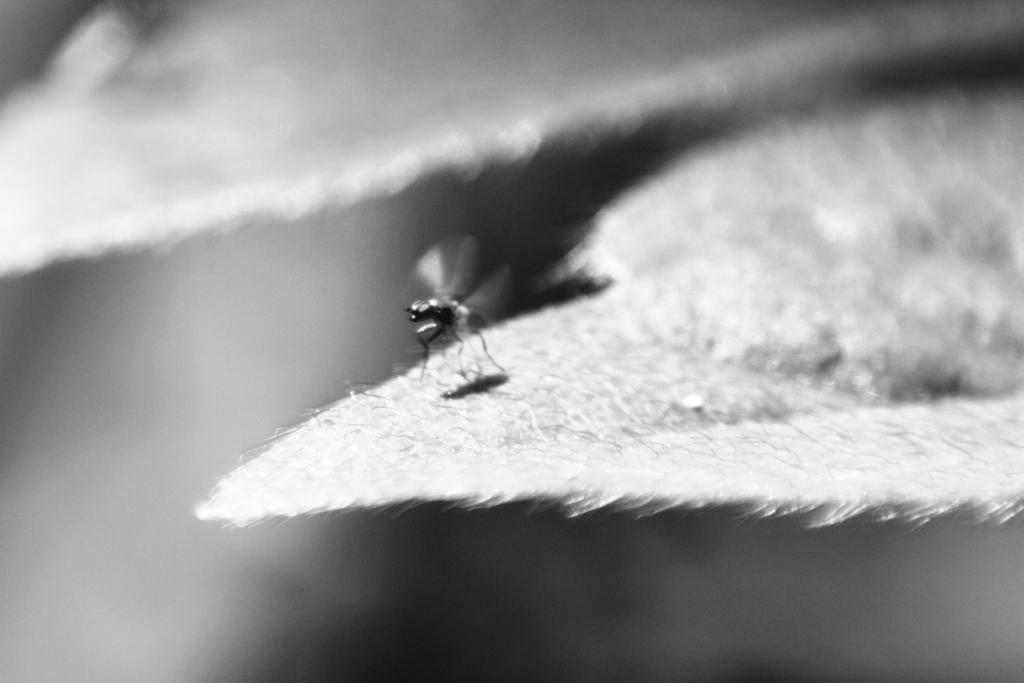What is the color scheme of the image? The image is black and white. What can be seen in the foreground of the image? There is a fly on a leaf in the foreground of the image. How would you describe the background of the image? The background of the image is blurry. How many girls are present in the image? There are no girls present in the image; it features a fly on a leaf in a black and white setting with a blurry background. 